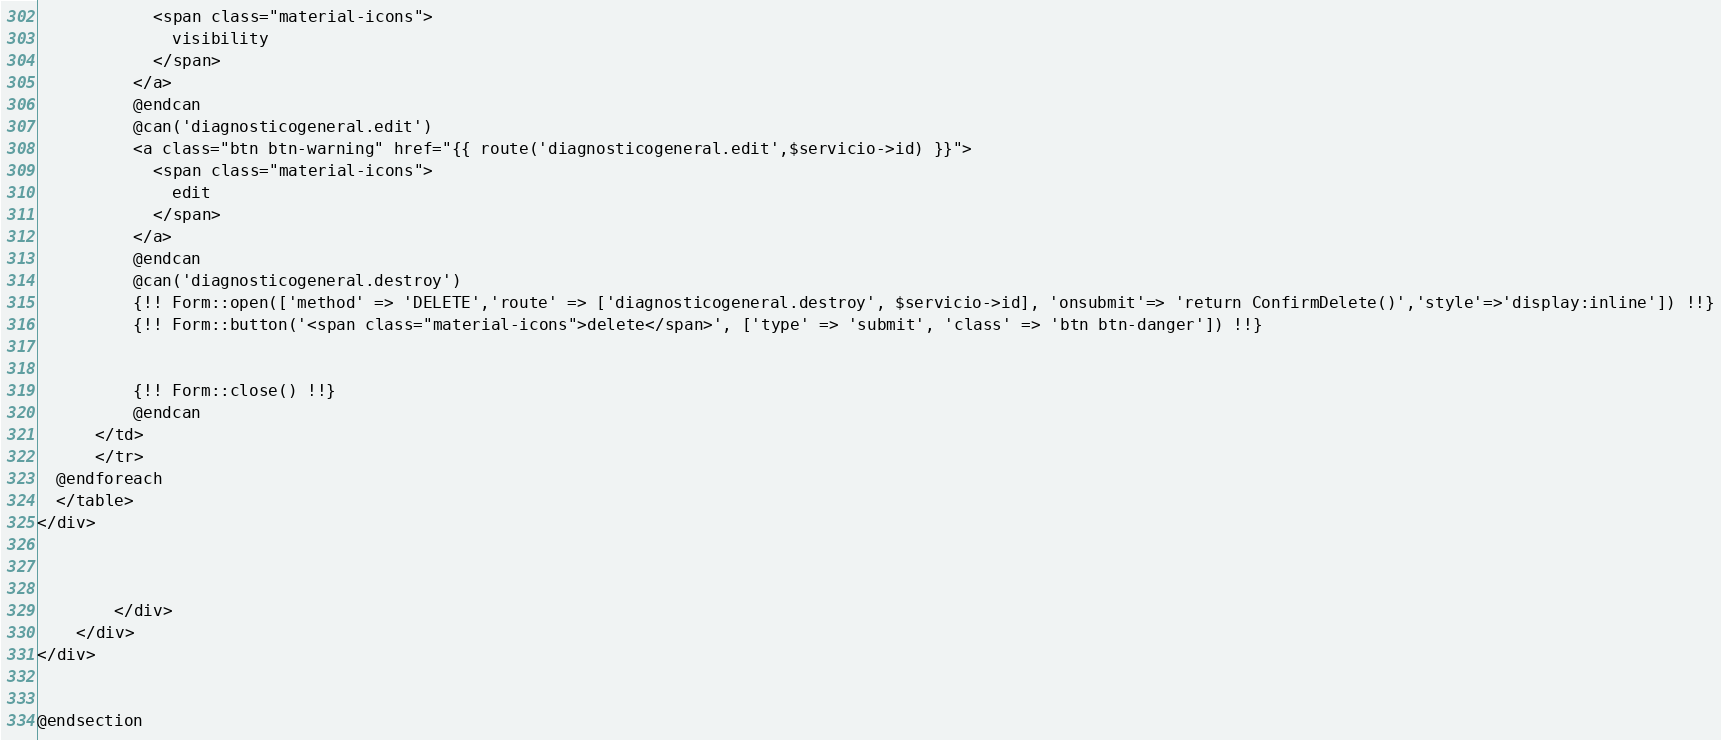<code> <loc_0><loc_0><loc_500><loc_500><_PHP_>            <span class="material-icons">
              visibility
            </span>
          </a>
          @endcan
          @can('diagnosticogeneral.edit')
          <a class="btn btn-warning" href="{{ route('diagnosticogeneral.edit',$servicio->id) }}">
            <span class="material-icons">
              edit
            </span>
          </a>
          @endcan
          @can('diagnosticogeneral.destroy')
          {!! Form::open(['method' => 'DELETE','route' => ['diagnosticogeneral.destroy', $servicio->id], 'onsubmit'=> 'return ConfirmDelete()','style'=>'display:inline']) !!}
          {!! Form::button('<span class="material-icons">delete</span>', ['type' => 'submit', 'class' => 'btn btn-danger']) !!}


          {!! Form::close() !!}
          @endcan
      </td>
      </tr>
  @endforeach
  </table>
</div>



        </div>
    </div>
</div>


@endsection
</code> 